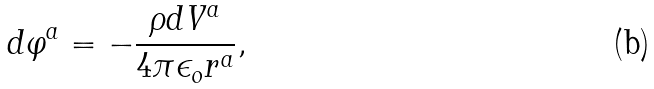Convert formula to latex. <formula><loc_0><loc_0><loc_500><loc_500>d \varphi ^ { a } = - \frac { \rho d V ^ { a } } { 4 \pi \epsilon _ { o } r ^ { a } } { , }</formula> 